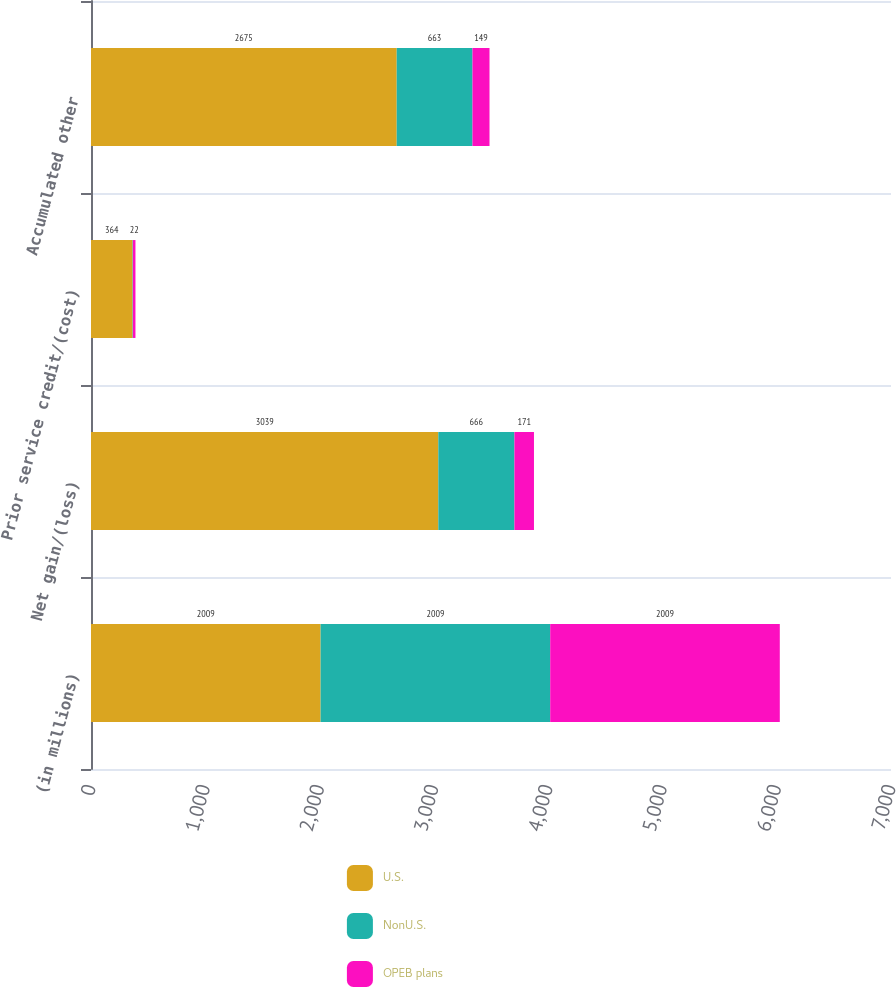Convert chart. <chart><loc_0><loc_0><loc_500><loc_500><stacked_bar_chart><ecel><fcel>(in millions)<fcel>Net gain/(loss)<fcel>Prior service credit/(cost)<fcel>Accumulated other<nl><fcel>U.S.<fcel>2009<fcel>3039<fcel>364<fcel>2675<nl><fcel>NonU.S.<fcel>2009<fcel>666<fcel>3<fcel>663<nl><fcel>OPEB plans<fcel>2009<fcel>171<fcel>22<fcel>149<nl></chart> 